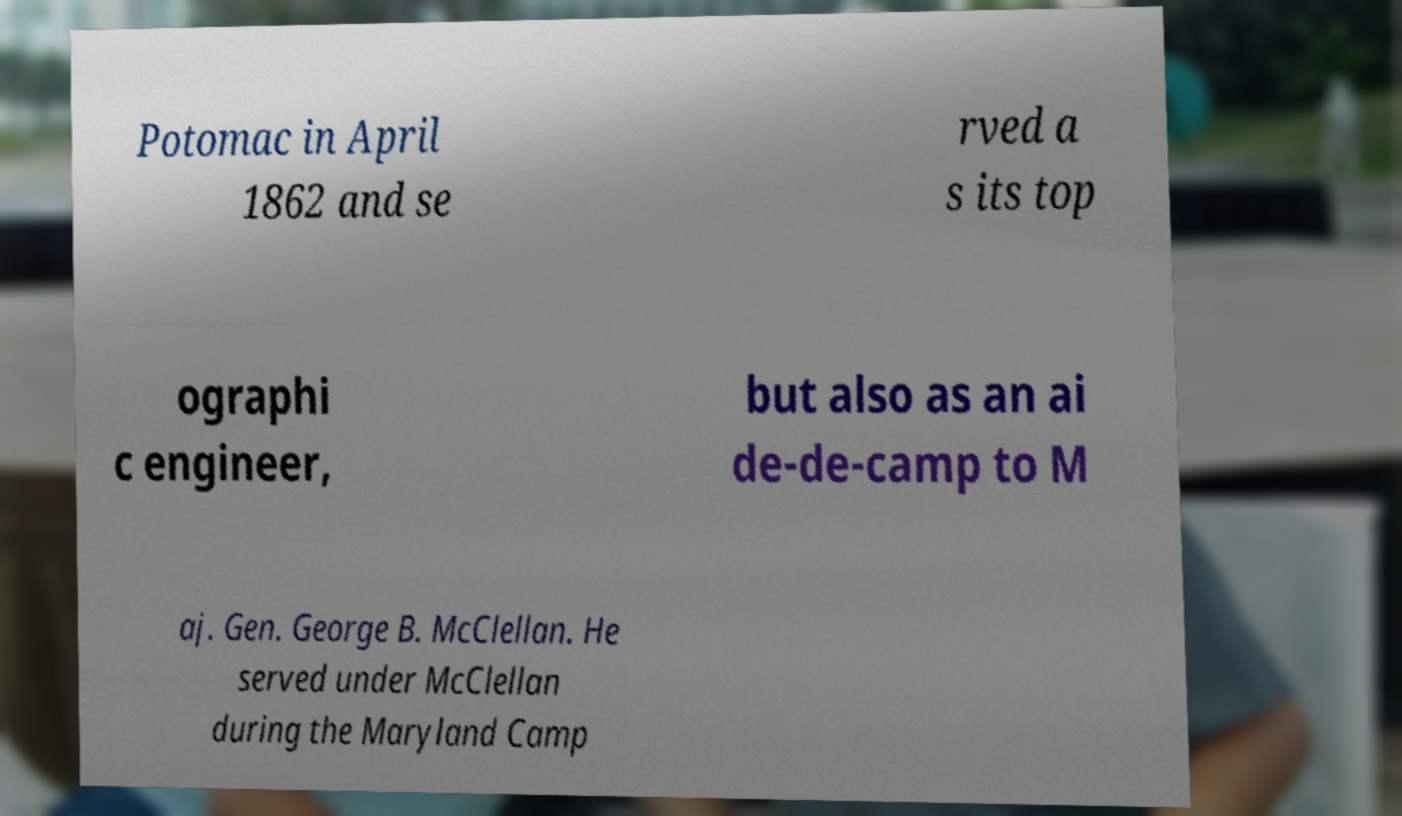Could you extract and type out the text from this image? Potomac in April 1862 and se rved a s its top ographi c engineer, but also as an ai de-de-camp to M aj. Gen. George B. McClellan. He served under McClellan during the Maryland Camp 